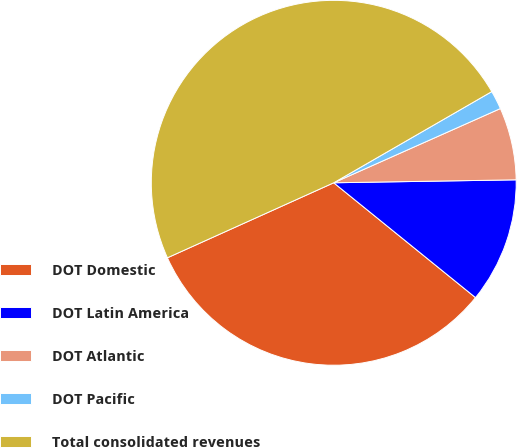<chart> <loc_0><loc_0><loc_500><loc_500><pie_chart><fcel>DOT Domestic<fcel>DOT Latin America<fcel>DOT Atlantic<fcel>DOT Pacific<fcel>Total consolidated revenues<nl><fcel>32.42%<fcel>11.09%<fcel>6.41%<fcel>1.66%<fcel>48.41%<nl></chart> 